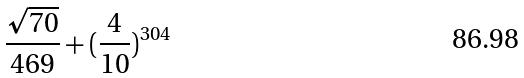<formula> <loc_0><loc_0><loc_500><loc_500>\frac { \sqrt { 7 0 } } { 4 6 9 } + ( \frac { 4 } { 1 0 } ) ^ { 3 0 4 }</formula> 